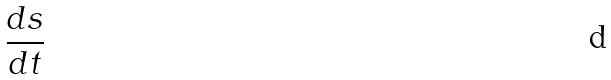Convert formula to latex. <formula><loc_0><loc_0><loc_500><loc_500>\frac { d s } { d t }</formula> 